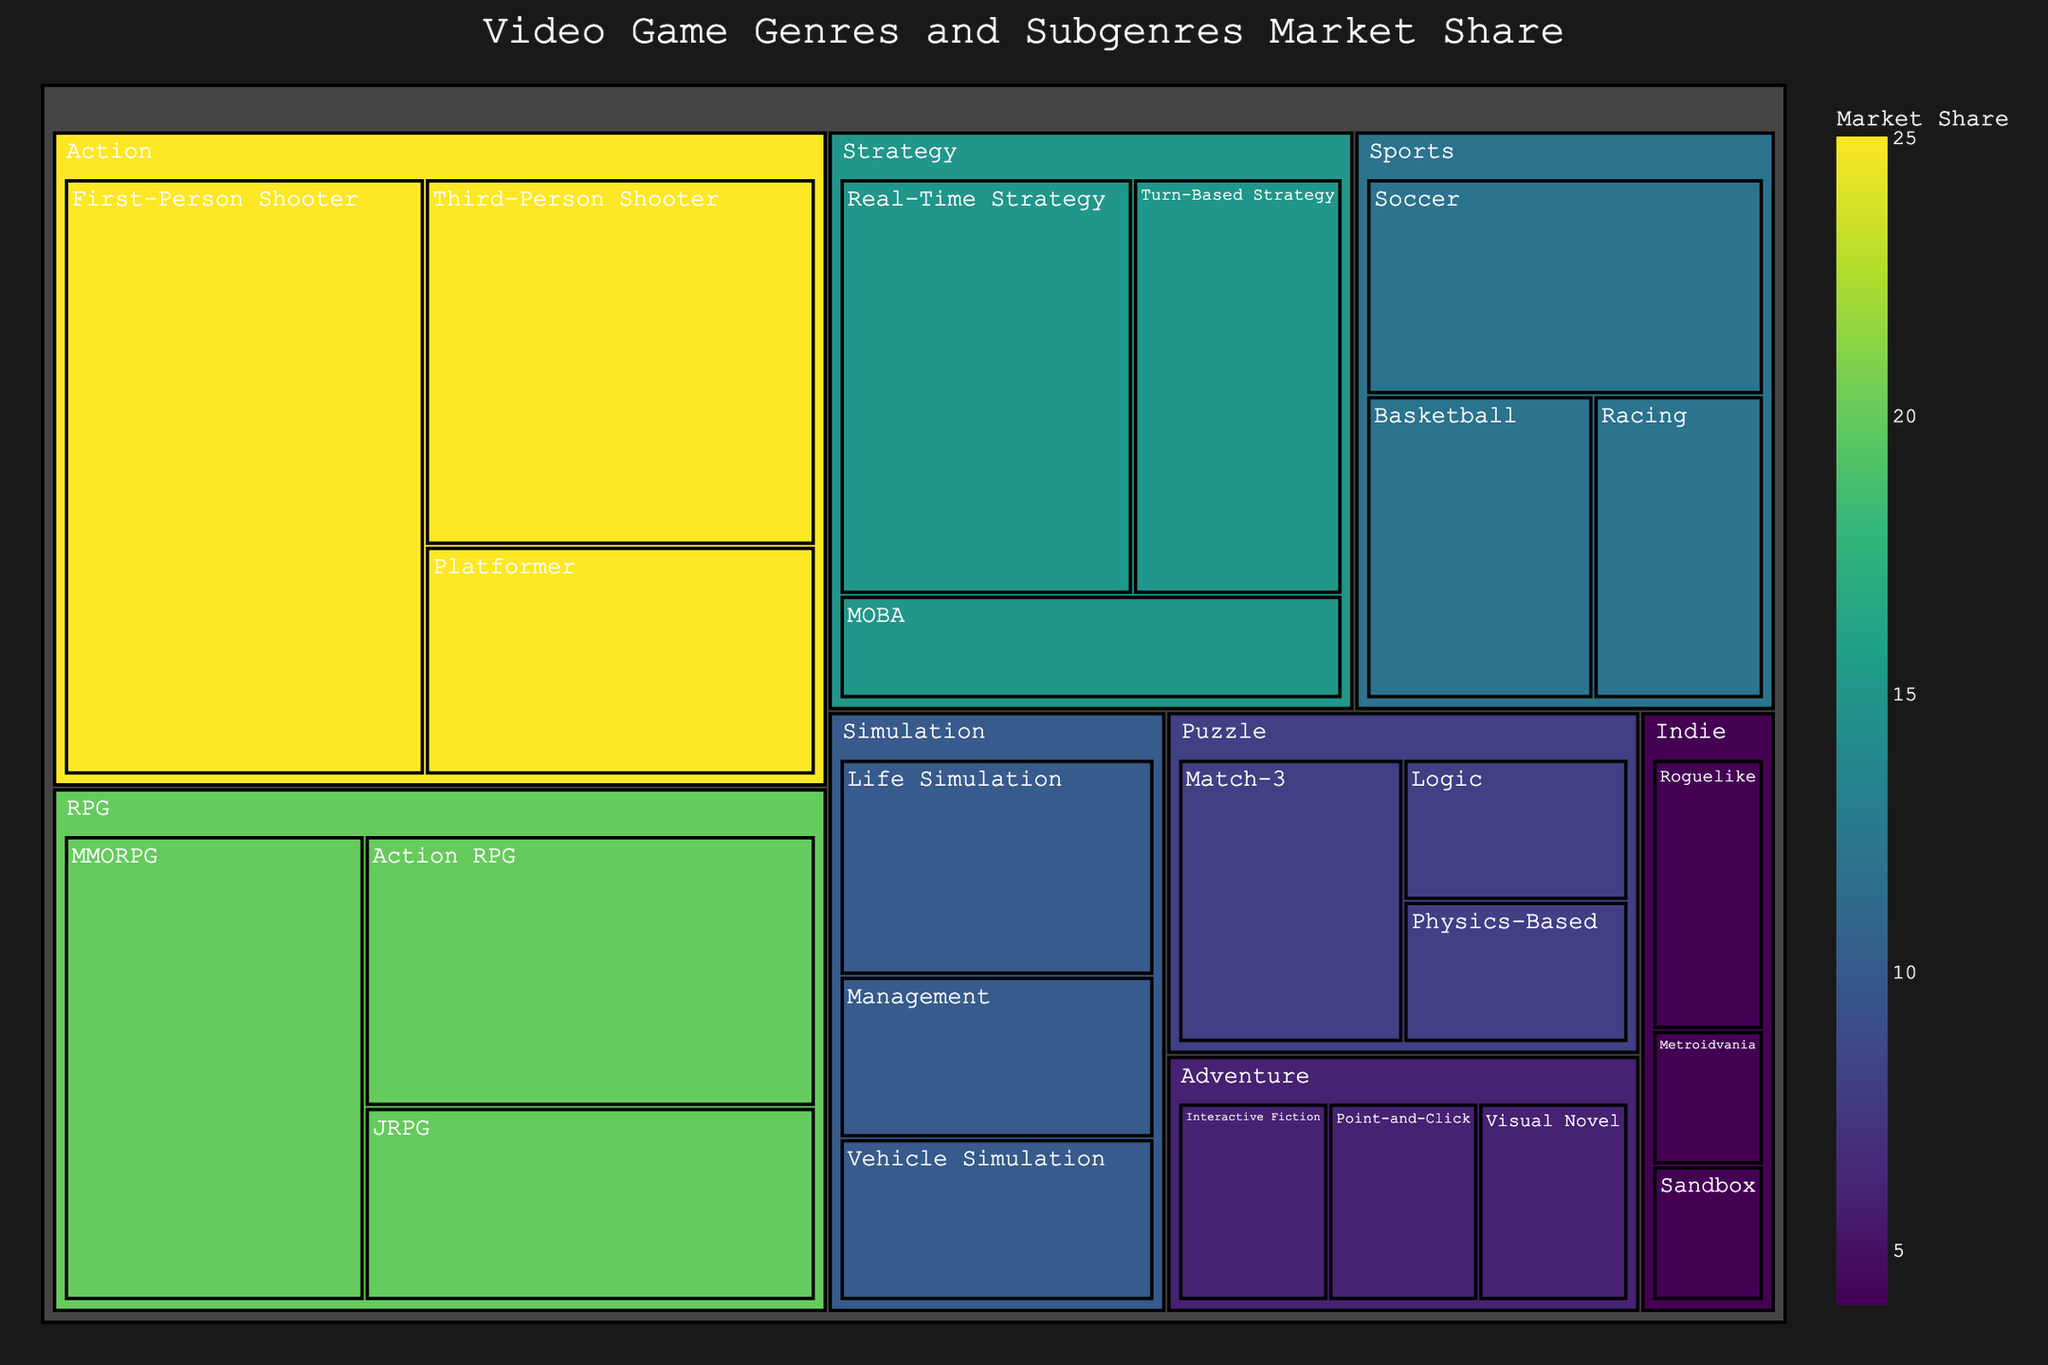What genre has the largest market share? The title and the color scale indicate that darker colors in the treemap represent a higher market share. The largest segment with the darkest color is the "Action" genre.
Answer: Action Which subgenre has the smallest share in the entire treemap? By looking for the smallest segmented block within the treemap, it is the "Metroidvania" subgenre under the "Indie" genre, with a share of 1%.
Answer: Metroidvania What is the combined market share of all the Strategy subgenres? The Strategy genre consists of three subgenres: Real-Time Strategy (7%), Turn-Based Strategy (5%), and MOBA (3%). Summing these values, we get 7 + 5 + 3 = 15%.
Answer: 15% Which genre has a larger market share, Sports or RPG? Observing their areas and relative sizes in the treemap, the RPG genre has a market share of 20%, while the Sports genre has a market share of 12%. Comparing these, RPG is larger than Sports.
Answer: RPG How does the market share of First-Person Shooter compare to Platformer? Under the Action genre, First-Person Shooter has a market share of 12%, while Platformer has 5%. Therefore, First-Person Shooter has a larger market share.
Answer: First-Person Shooter What is the market share difference between the RPG genre and the Puzzle genre? The RPG genre has a market share of 20%, and the Puzzle genre has a market share of 8%. The difference is 20 - 8 = 12%.
Answer: 12% Which subgenre in the Sports genre has the highest market share? Within the Sports genre, the Soccer subgenre has a market share of 5%, which is the highest compared to Basketball (4%) and Racing (3%).
Answer: Soccer Is the combined market share of the Adventure genre greater than that of the Indie genre? The Adventure genre has a market share of 6%, and the Indie genre has a market share of 4%. Since 6% is greater than 4%, the combined market share of Adventure is greater.
Answer: Yes Which subgenre within the Simulation genre shares the same market percentage? The Vehicle Simulation and Management subgenres both have a market share of 3% each within the Simulation genre.
Answer: Vehicle Simulation and Management How does the market share of the Life Simulation subgenre compare to the entire Adventure genre? The Life Simulation subgenre has a market share of 4%, whereas the entire Adventure genre has a market share of 6%. The Adventure genre has a larger market share.
Answer: Adventure genre 